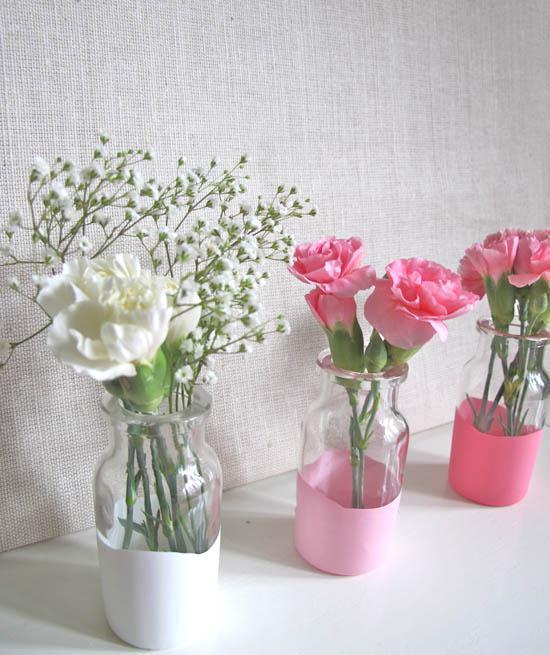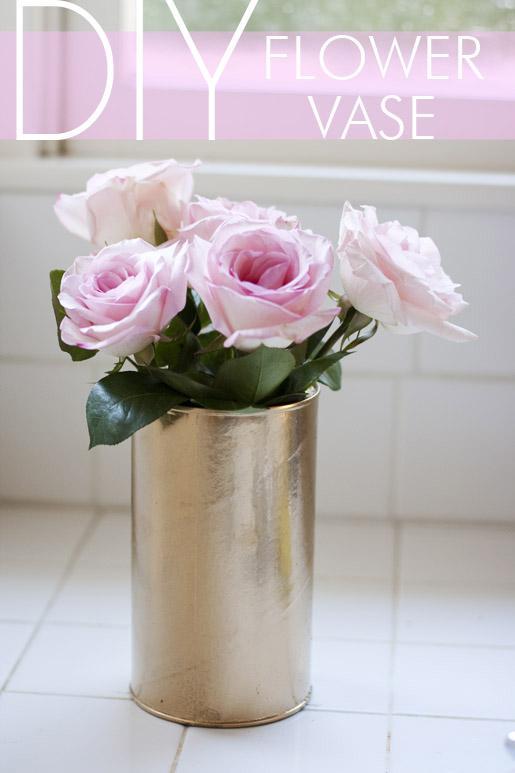The first image is the image on the left, the second image is the image on the right. Given the left and right images, does the statement "There are more vases in the image on the left." hold true? Answer yes or no. Yes. 